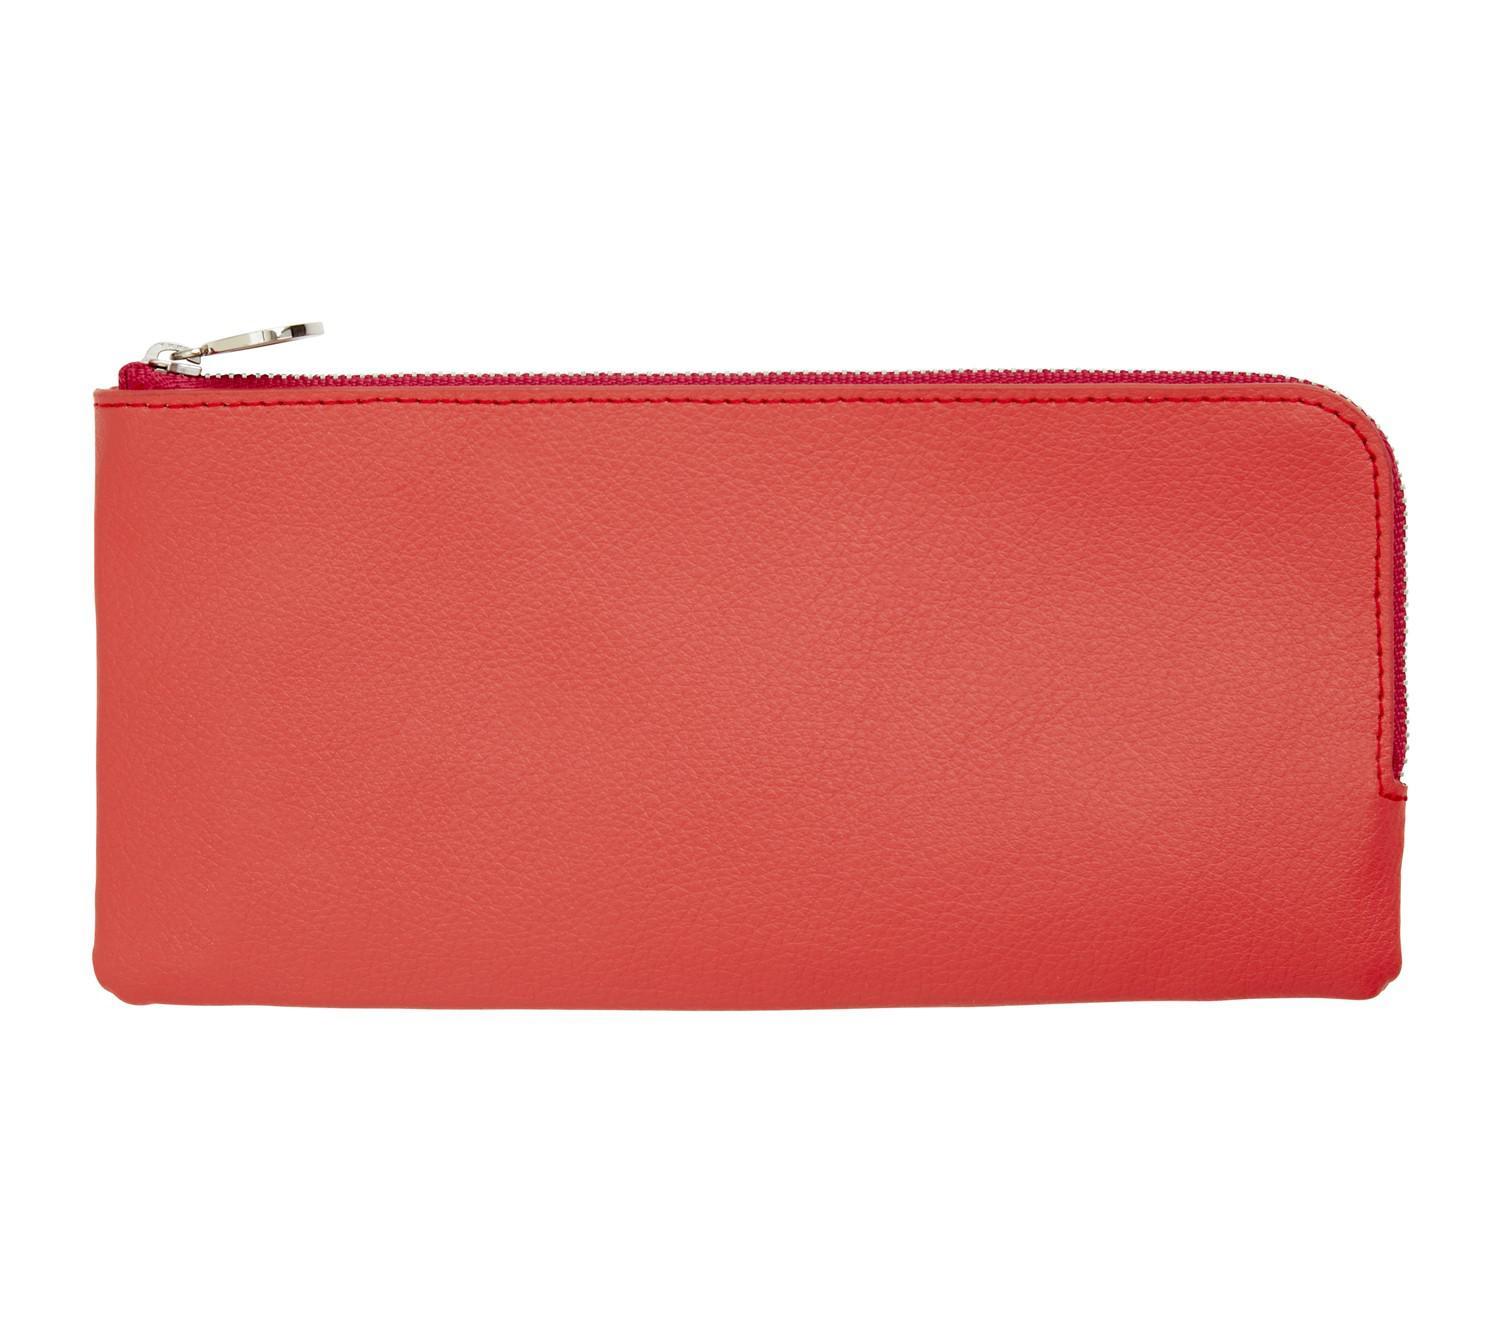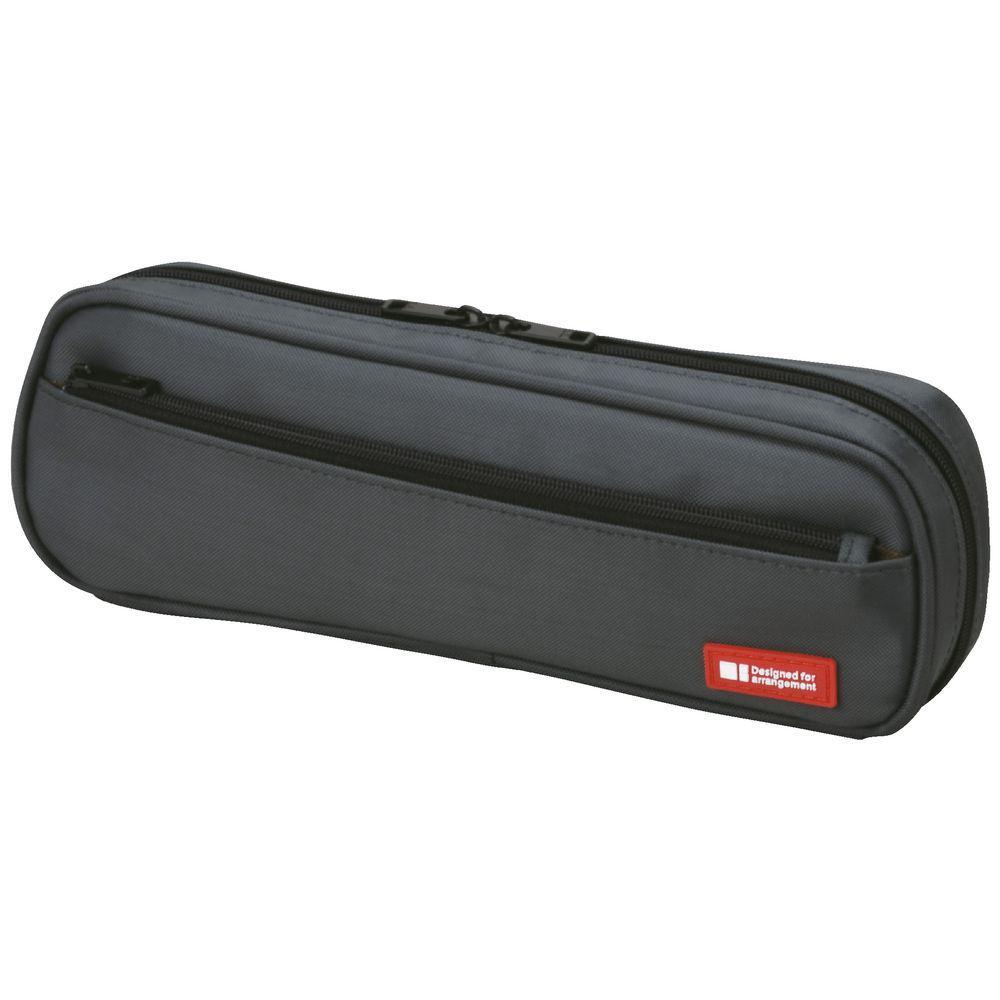The first image is the image on the left, the second image is the image on the right. Examine the images to the left and right. Is the description "Two pencil cases with top zippers are different sizes and only one has a visible tag affixed." accurate? Answer yes or no. Yes. The first image is the image on the left, the second image is the image on the right. Given the left and right images, does the statement "One case is solid color and rectangular with rounded edges, and has two zipper pulls on top to zip the case open, and the other case features a bright warm color." hold true? Answer yes or no. Yes. 